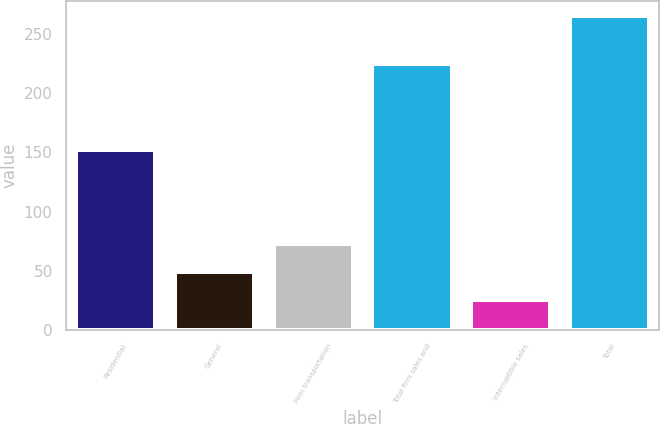Convert chart. <chart><loc_0><loc_0><loc_500><loc_500><bar_chart><fcel>Residential<fcel>General<fcel>Firm transportation<fcel>Total firm sales and<fcel>Interruptible sales<fcel>Total<nl><fcel>152<fcel>49<fcel>73<fcel>225<fcel>25<fcel>265<nl></chart> 